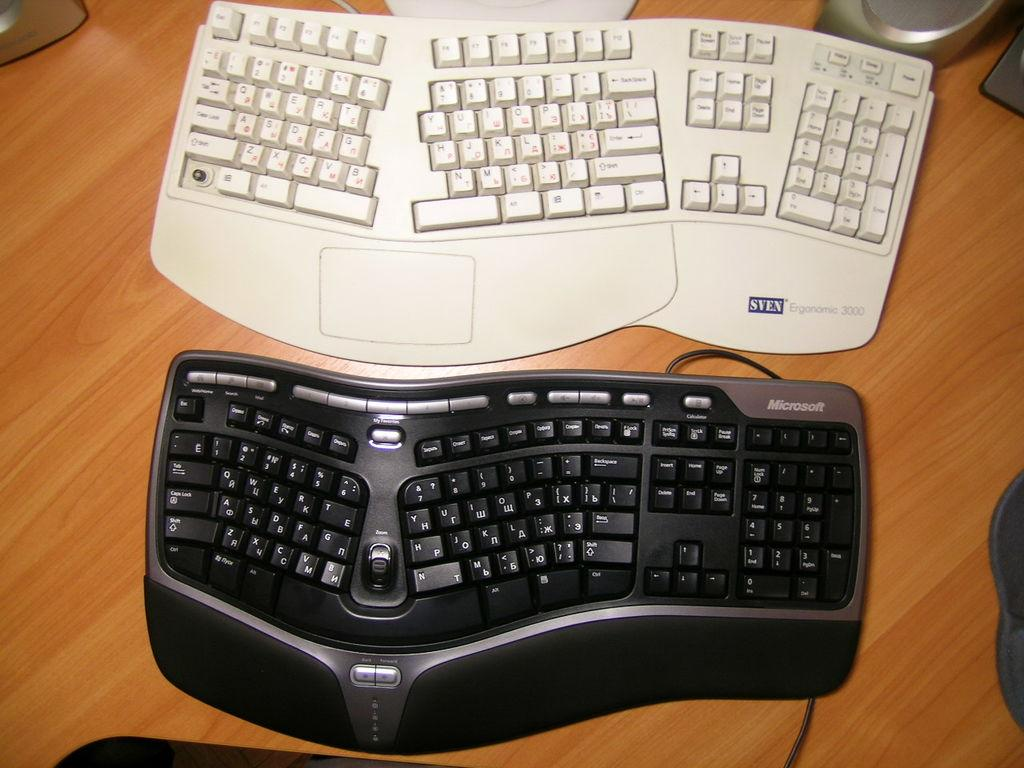<image>
Render a clear and concise summary of the photo. A Sven brand white keyboard sits on a desk with a black keyboard. 